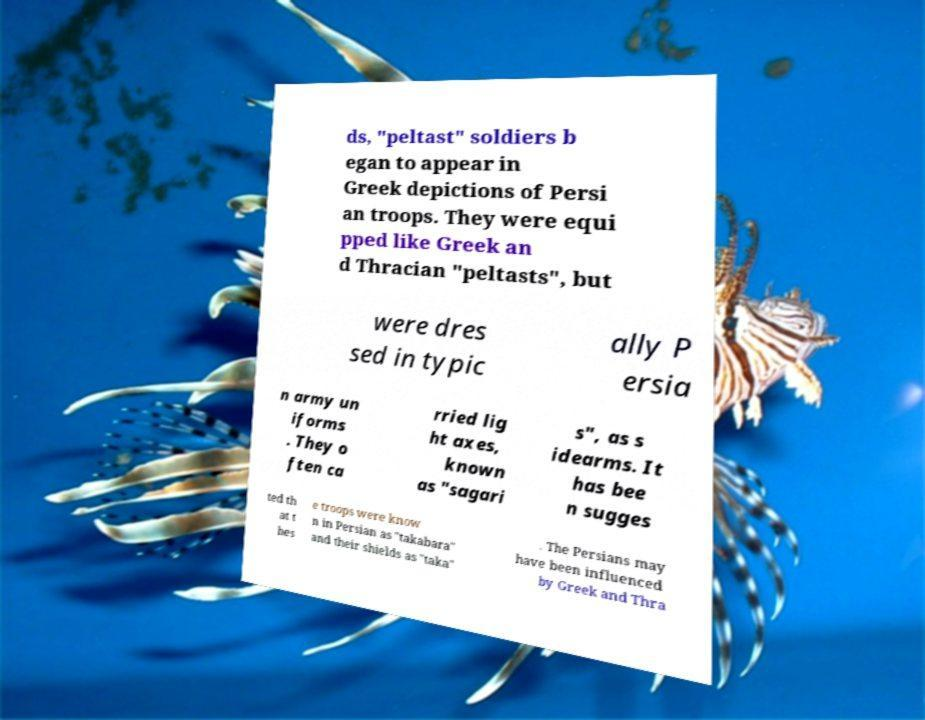Please identify and transcribe the text found in this image. ds, "peltast" soldiers b egan to appear in Greek depictions of Persi an troops. They were equi pped like Greek an d Thracian "peltasts", but were dres sed in typic ally P ersia n army un iforms . They o ften ca rried lig ht axes, known as "sagari s", as s idearms. It has bee n sugges ted th at t hes e troops were know n in Persian as "takabara" and their shields as "taka" . The Persians may have been influenced by Greek and Thra 